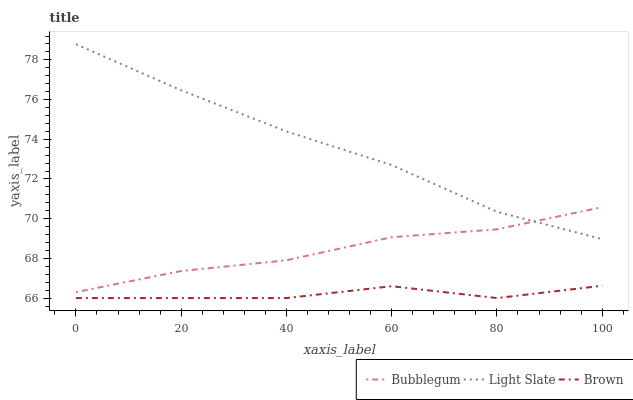Does Brown have the minimum area under the curve?
Answer yes or no. Yes. Does Light Slate have the maximum area under the curve?
Answer yes or no. Yes. Does Bubblegum have the minimum area under the curve?
Answer yes or no. No. Does Bubblegum have the maximum area under the curve?
Answer yes or no. No. Is Light Slate the smoothest?
Answer yes or no. Yes. Is Brown the roughest?
Answer yes or no. Yes. Is Bubblegum the smoothest?
Answer yes or no. No. Is Bubblegum the roughest?
Answer yes or no. No. Does Brown have the lowest value?
Answer yes or no. Yes. Does Bubblegum have the lowest value?
Answer yes or no. No. Does Light Slate have the highest value?
Answer yes or no. Yes. Does Bubblegum have the highest value?
Answer yes or no. No. Is Brown less than Bubblegum?
Answer yes or no. Yes. Is Light Slate greater than Brown?
Answer yes or no. Yes. Does Bubblegum intersect Light Slate?
Answer yes or no. Yes. Is Bubblegum less than Light Slate?
Answer yes or no. No. Is Bubblegum greater than Light Slate?
Answer yes or no. No. Does Brown intersect Bubblegum?
Answer yes or no. No. 